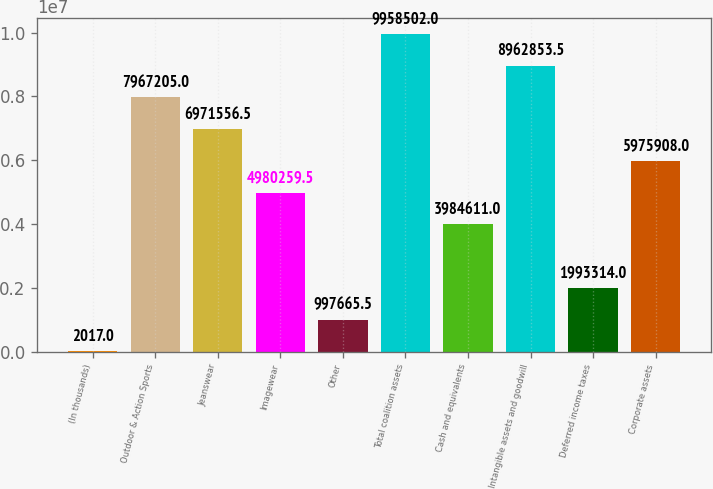Convert chart to OTSL. <chart><loc_0><loc_0><loc_500><loc_500><bar_chart><fcel>(In thousands)<fcel>Outdoor & Action Sports<fcel>Jeanswear<fcel>Imagewear<fcel>Other<fcel>Total coalition assets<fcel>Cash and equivalents<fcel>Intangible assets and goodwill<fcel>Deferred income taxes<fcel>Corporate assets<nl><fcel>2017<fcel>7.9672e+06<fcel>6.97156e+06<fcel>4.98026e+06<fcel>997666<fcel>9.9585e+06<fcel>3.98461e+06<fcel>8.96285e+06<fcel>1.99331e+06<fcel>5.97591e+06<nl></chart> 